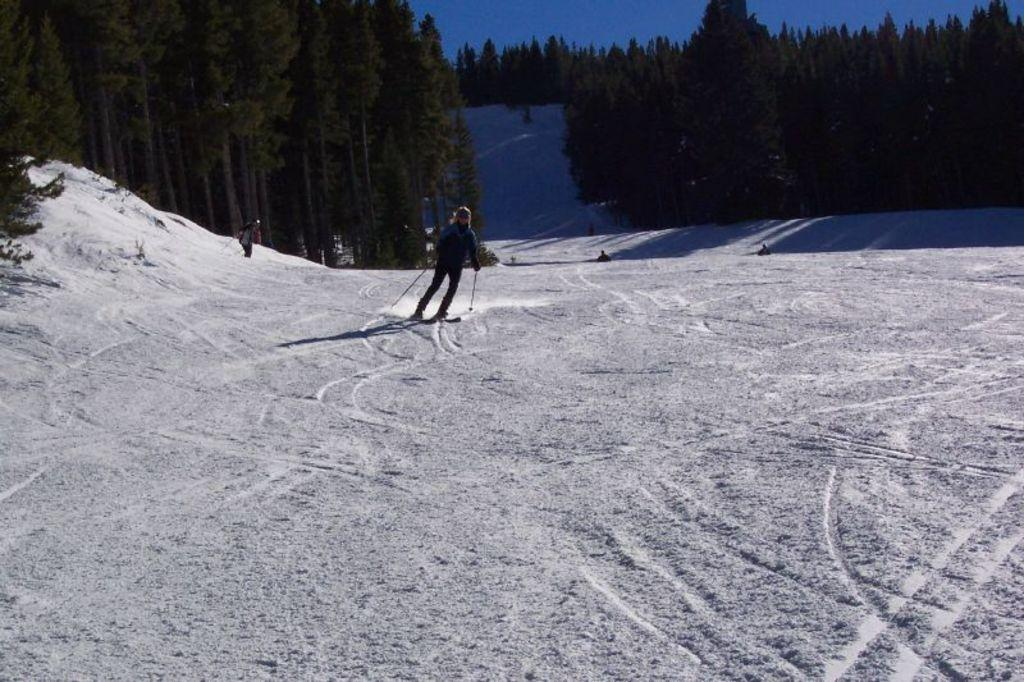What is the condition of the ground in the image? The ground is covered with snow. What are the people in the image using for transportation? The people are on skiboards. What do the people on skiboards have in their hands? The people are holding ski sticks. What type of natural environment can be seen in the image? There are trees visible in the image. What is visible in the sky in the image? The sky is visible in the image. Where are the apples being stored in the image? There are no apples present in the image. What type of boats can be seen in the image? There are no boats present in the image. 